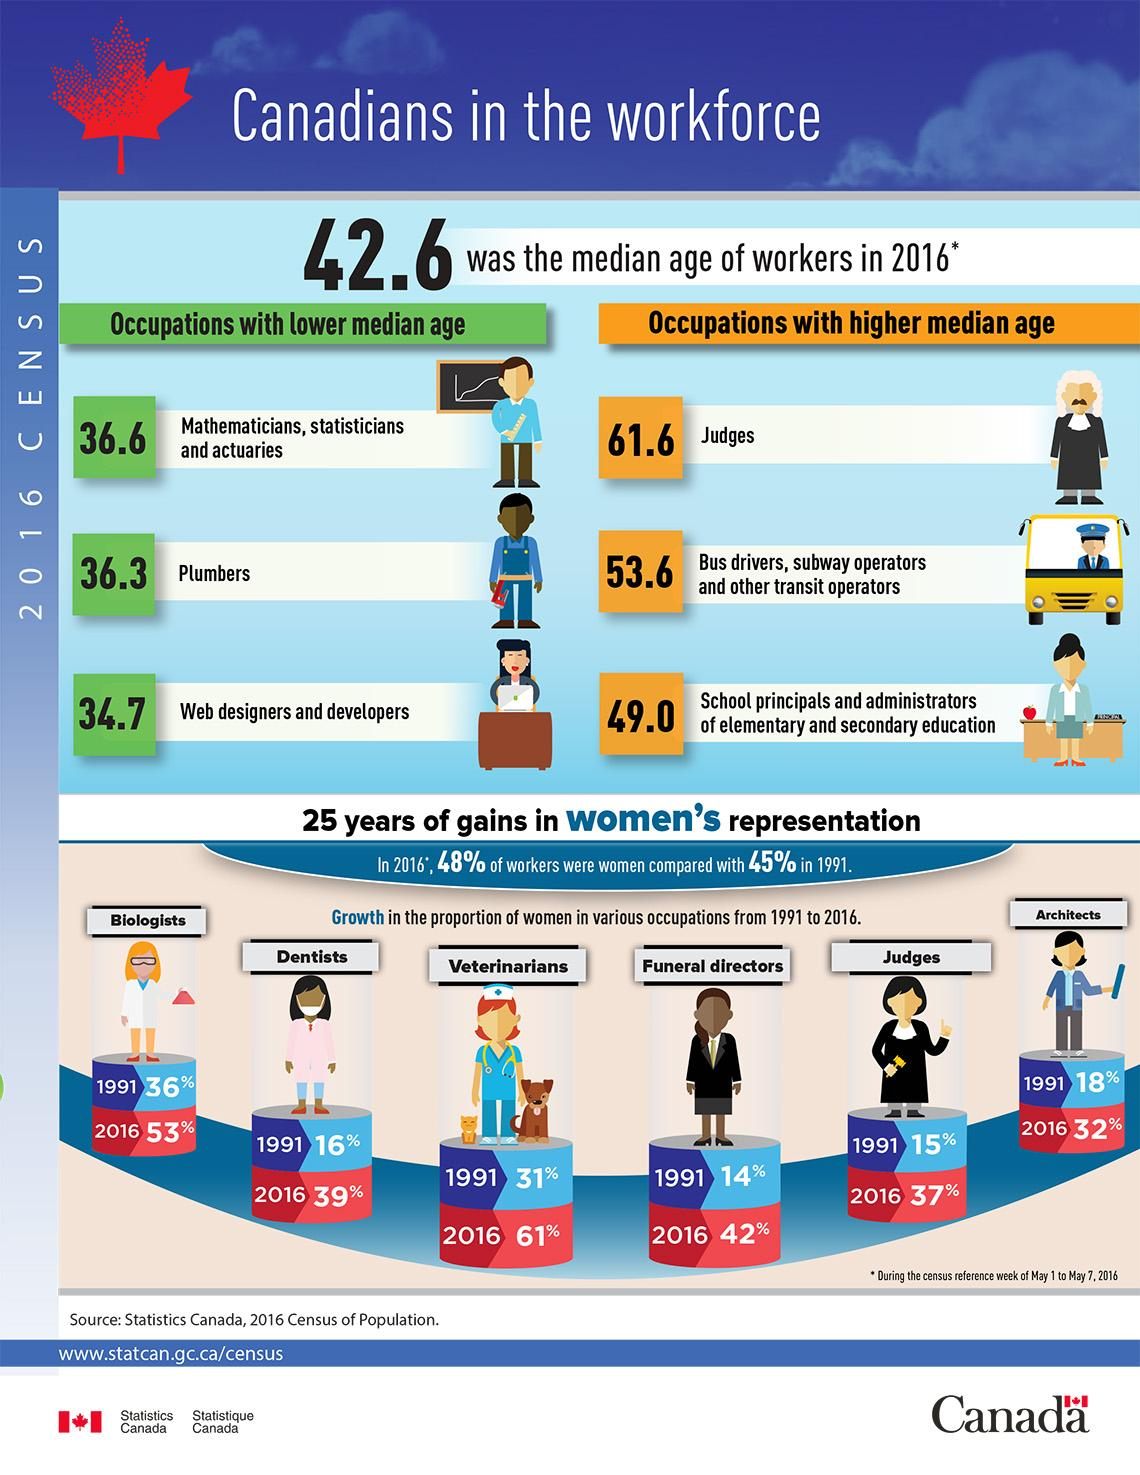List a handful of essential elements in this visual. According to data from 2016, judges were the occupation with the highest median age in Canada. The median age of plumbers in Canada was 36.3 years in 2016. In 1991, approximately 31% of Canadian women were veterinarians. In 2016, it was reported that 32% of women in Canada were architects. In 2016, it was reported that 39% of women in Canada were dentists. 